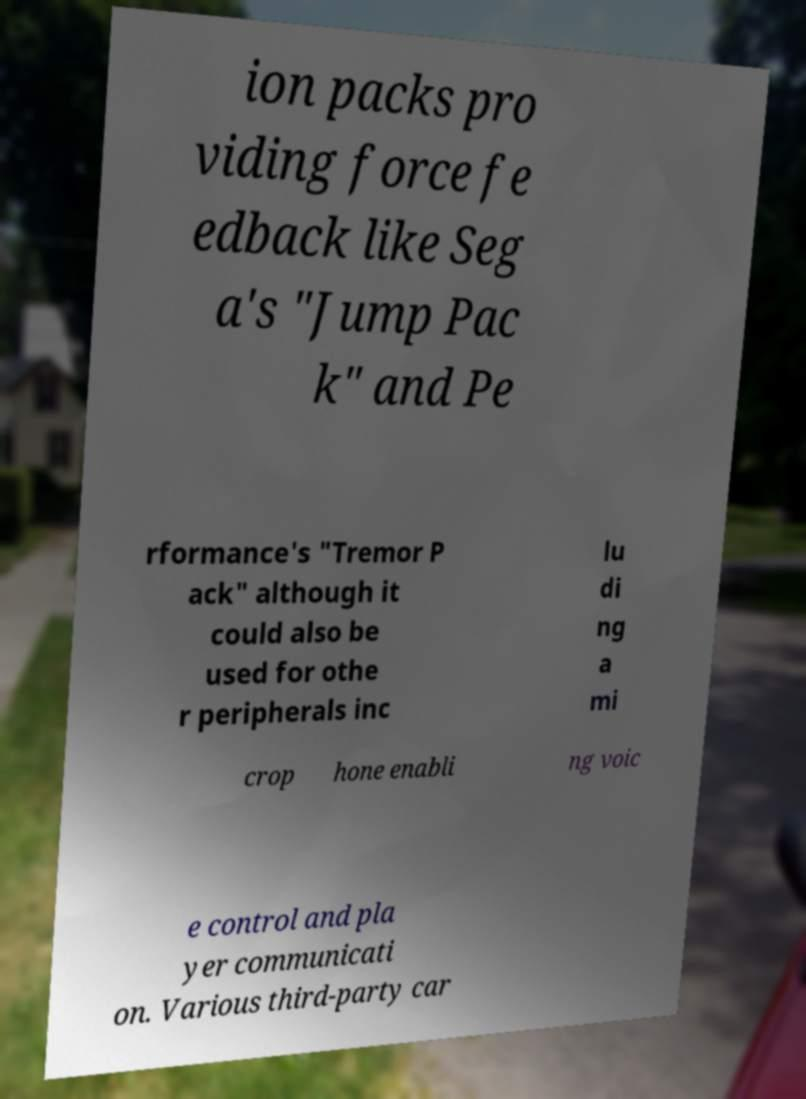Can you read and provide the text displayed in the image?This photo seems to have some interesting text. Can you extract and type it out for me? ion packs pro viding force fe edback like Seg a's "Jump Pac k" and Pe rformance's "Tremor P ack" although it could also be used for othe r peripherals inc lu di ng a mi crop hone enabli ng voic e control and pla yer communicati on. Various third-party car 